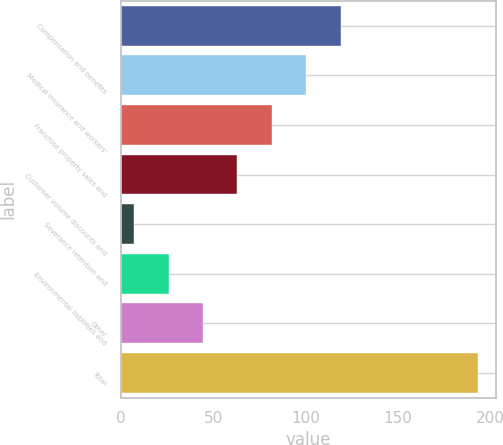Convert chart to OTSL. <chart><loc_0><loc_0><loc_500><loc_500><bar_chart><fcel>Compensation and benefits<fcel>Medical insurance and workers'<fcel>Franchise property sales and<fcel>Customer volume discounts and<fcel>Severance retention and<fcel>Environmental liabilities and<fcel>Other<fcel>Total<nl><fcel>119.02<fcel>100.4<fcel>81.78<fcel>63.16<fcel>7.3<fcel>25.92<fcel>44.54<fcel>193.5<nl></chart> 